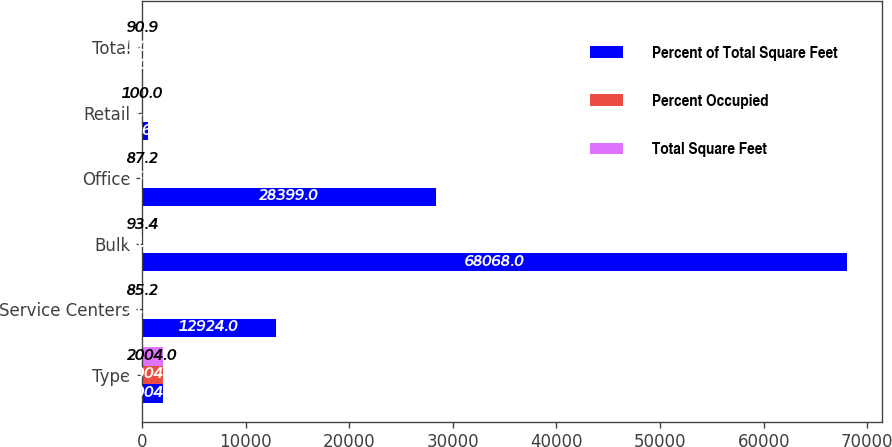Convert chart to OTSL. <chart><loc_0><loc_0><loc_500><loc_500><stacked_bar_chart><ecel><fcel>Type<fcel>Service Centers<fcel>Bulk<fcel>Office<fcel>Retail<fcel>Total<nl><fcel>Percent of Total Square Feet<fcel>2004<fcel>12924<fcel>68068<fcel>28399<fcel>596<fcel>100<nl><fcel>Percent Occupied<fcel>2004<fcel>11.8<fcel>61.9<fcel>25.8<fcel>0.5<fcel>100<nl><fcel>Total Square Feet<fcel>2004<fcel>85.2<fcel>93.4<fcel>87.2<fcel>100<fcel>90.9<nl></chart> 